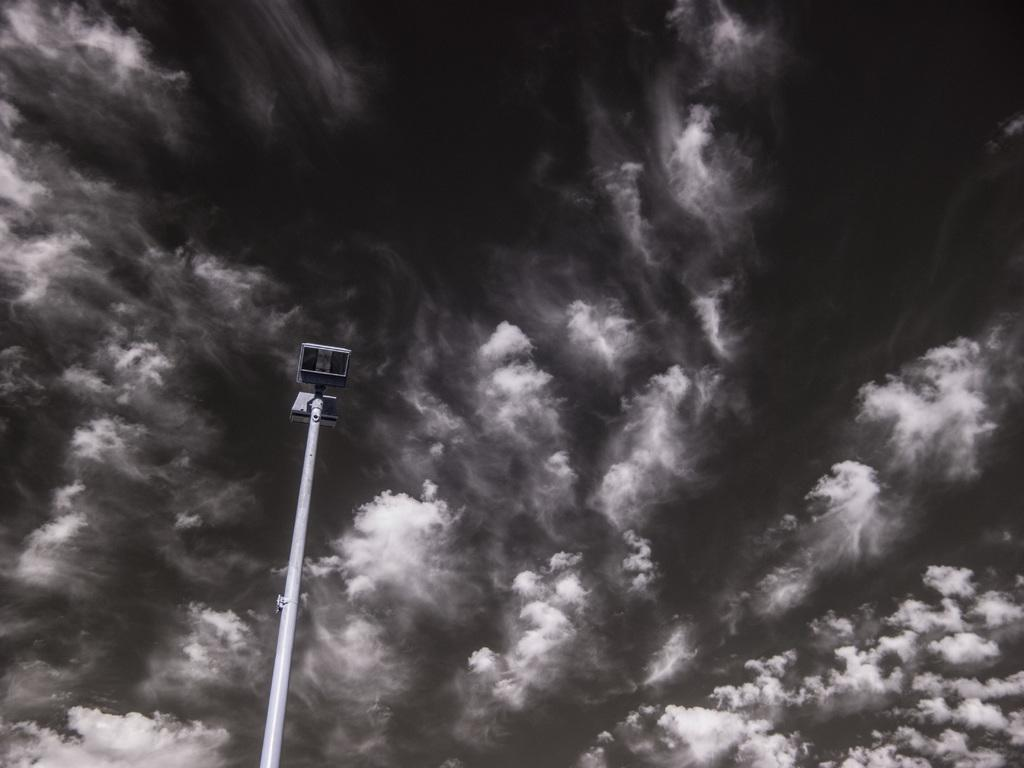What structure can be seen in the image? There is a light-pole in the image. What color scheme is used in the image? The image is in black and white. How many legs does the clock have in the image? There is no clock present in the image, so it is not possible to determine the number of legs it might have. 